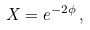Convert formula to latex. <formula><loc_0><loc_0><loc_500><loc_500>X = e ^ { - 2 \phi } \, ,</formula> 